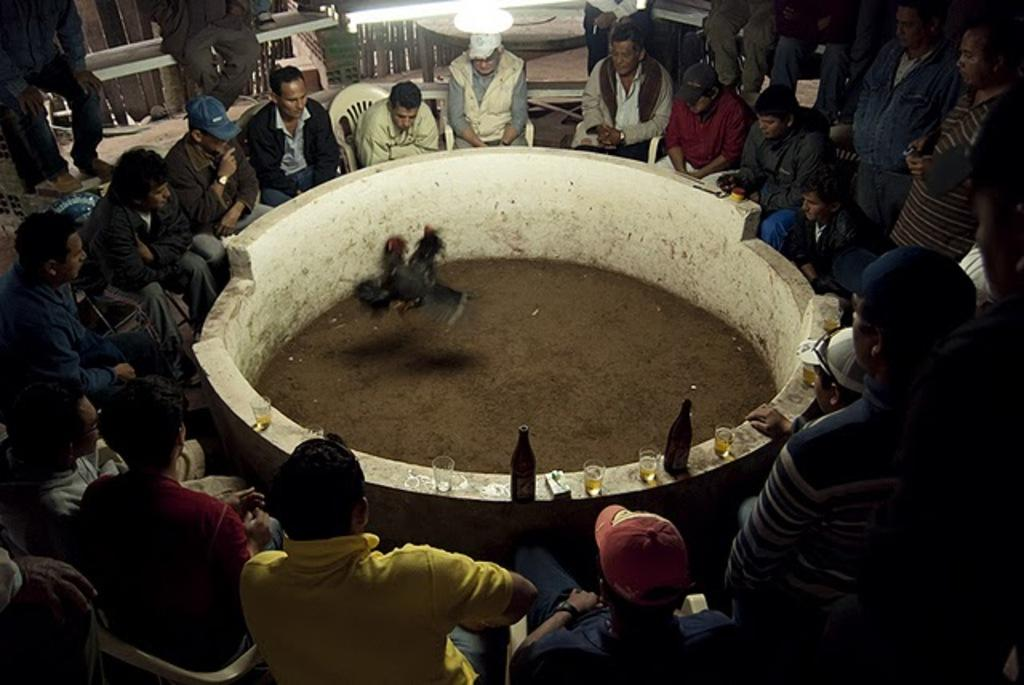What are the people in the image doing? There is a group of people sitting on chairs in the image. What animals can be seen in the image? There are hens in the image. What piece of furniture is present in the image? There is a table in the image. What is the source of light in the image? There is a light in the image. What type of objects are on the table? There are glasses and bottles in the image. What type of flag is being waved by the people in the image? There is no flag present in the image; the people are sitting on chairs. What is the tax rate for the hens in the image? There is no mention of taxes in the image, and hens are not subject to taxation. 